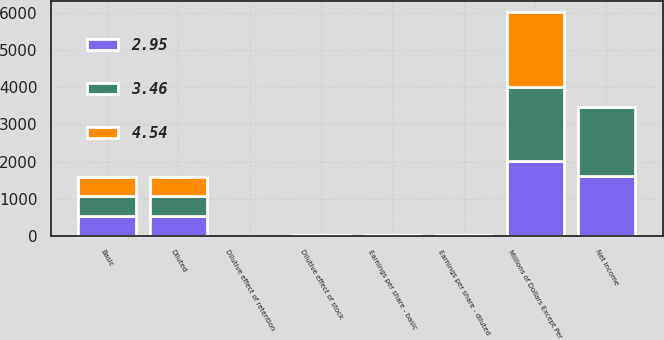Convert chart. <chart><loc_0><loc_0><loc_500><loc_500><stacked_bar_chart><ecel><fcel>Millions of Dollars Except Per<fcel>Net income<fcel>Basic<fcel>Dilutive effect of stock<fcel>Dilutive effect of retention<fcel>Diluted<fcel>Earnings per share - basic<fcel>Earnings per share - diluted<nl><fcel>4.54<fcel>2008<fcel>4.58<fcel>510.6<fcel>3.4<fcel>1<fcel>515<fcel>4.58<fcel>4.54<nl><fcel>3.46<fcel>2007<fcel>1855<fcel>531.9<fcel>4.2<fcel>0.7<fcel>536.8<fcel>3.49<fcel>3.46<nl><fcel>2.95<fcel>2006<fcel>1606<fcel>538.9<fcel>4<fcel>1<fcel>543.9<fcel>2.98<fcel>2.95<nl></chart> 